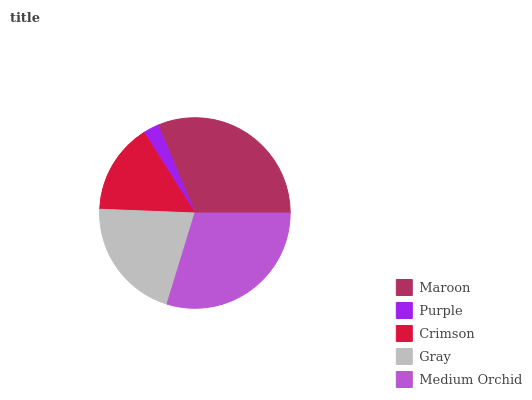Is Purple the minimum?
Answer yes or no. Yes. Is Maroon the maximum?
Answer yes or no. Yes. Is Crimson the minimum?
Answer yes or no. No. Is Crimson the maximum?
Answer yes or no. No. Is Crimson greater than Purple?
Answer yes or no. Yes. Is Purple less than Crimson?
Answer yes or no. Yes. Is Purple greater than Crimson?
Answer yes or no. No. Is Crimson less than Purple?
Answer yes or no. No. Is Gray the high median?
Answer yes or no. Yes. Is Gray the low median?
Answer yes or no. Yes. Is Crimson the high median?
Answer yes or no. No. Is Purple the low median?
Answer yes or no. No. 